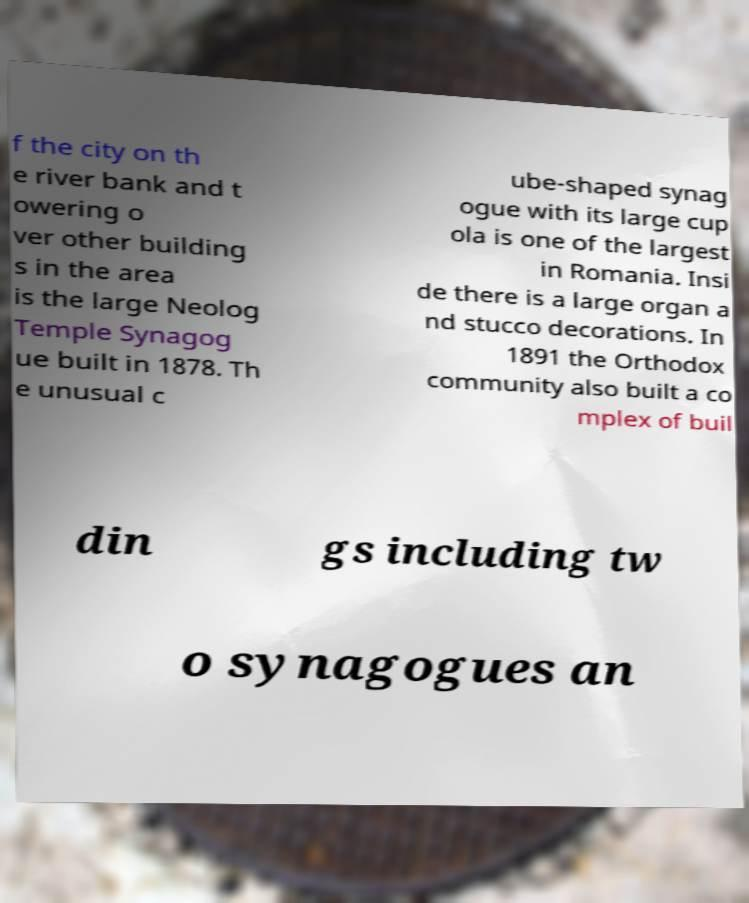For documentation purposes, I need the text within this image transcribed. Could you provide that? f the city on th e river bank and t owering o ver other building s in the area is the large Neolog Temple Synagog ue built in 1878. Th e unusual c ube-shaped synag ogue with its large cup ola is one of the largest in Romania. Insi de there is a large organ a nd stucco decorations. In 1891 the Orthodox community also built a co mplex of buil din gs including tw o synagogues an 